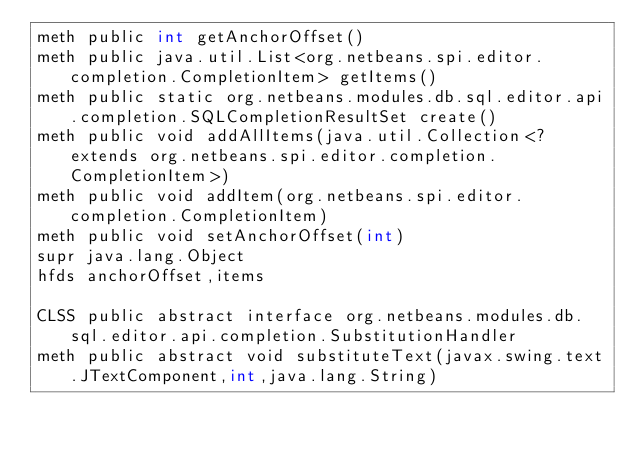<code> <loc_0><loc_0><loc_500><loc_500><_SML_>meth public int getAnchorOffset()
meth public java.util.List<org.netbeans.spi.editor.completion.CompletionItem> getItems()
meth public static org.netbeans.modules.db.sql.editor.api.completion.SQLCompletionResultSet create()
meth public void addAllItems(java.util.Collection<? extends org.netbeans.spi.editor.completion.CompletionItem>)
meth public void addItem(org.netbeans.spi.editor.completion.CompletionItem)
meth public void setAnchorOffset(int)
supr java.lang.Object
hfds anchorOffset,items

CLSS public abstract interface org.netbeans.modules.db.sql.editor.api.completion.SubstitutionHandler
meth public abstract void substituteText(javax.swing.text.JTextComponent,int,java.lang.String)

</code> 